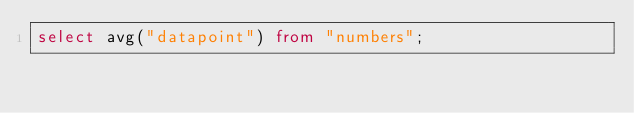Convert code to text. <code><loc_0><loc_0><loc_500><loc_500><_SQL_>select avg("datapoint") from "numbers";
</code> 